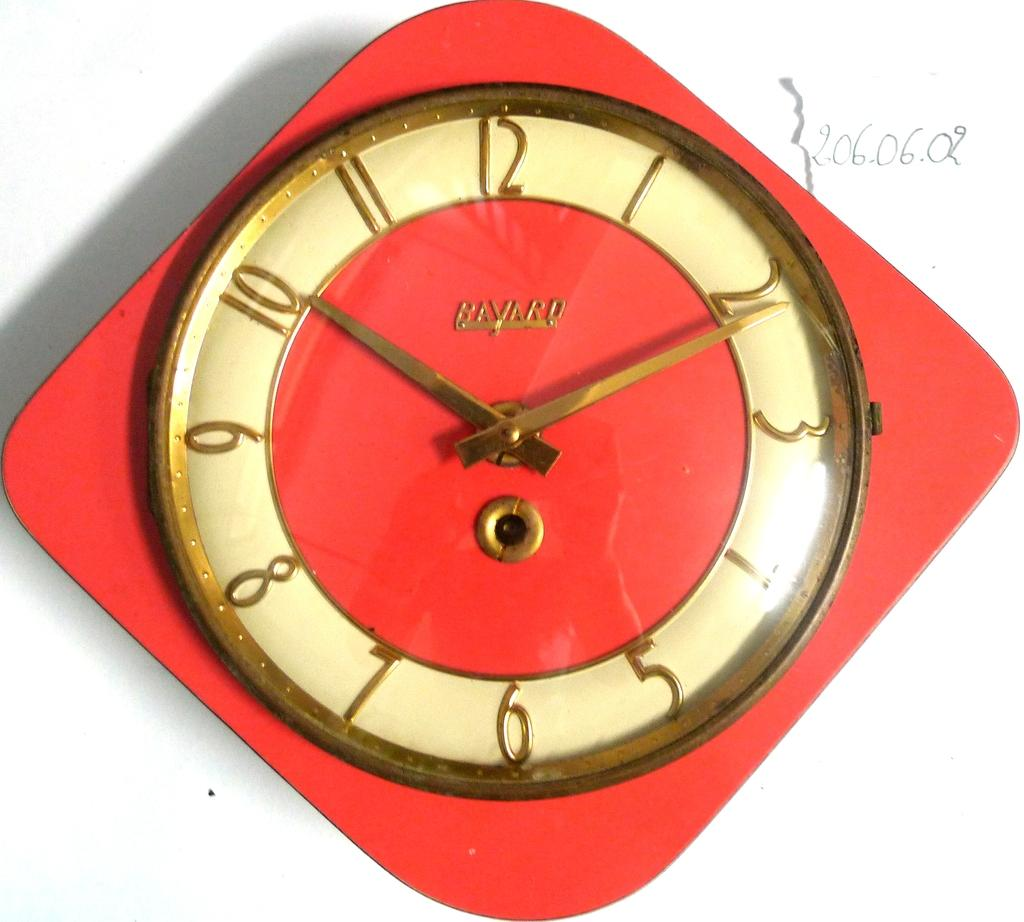<image>
Describe the image concisely. A red and white Bayard clock showing it to be ten after ten. 